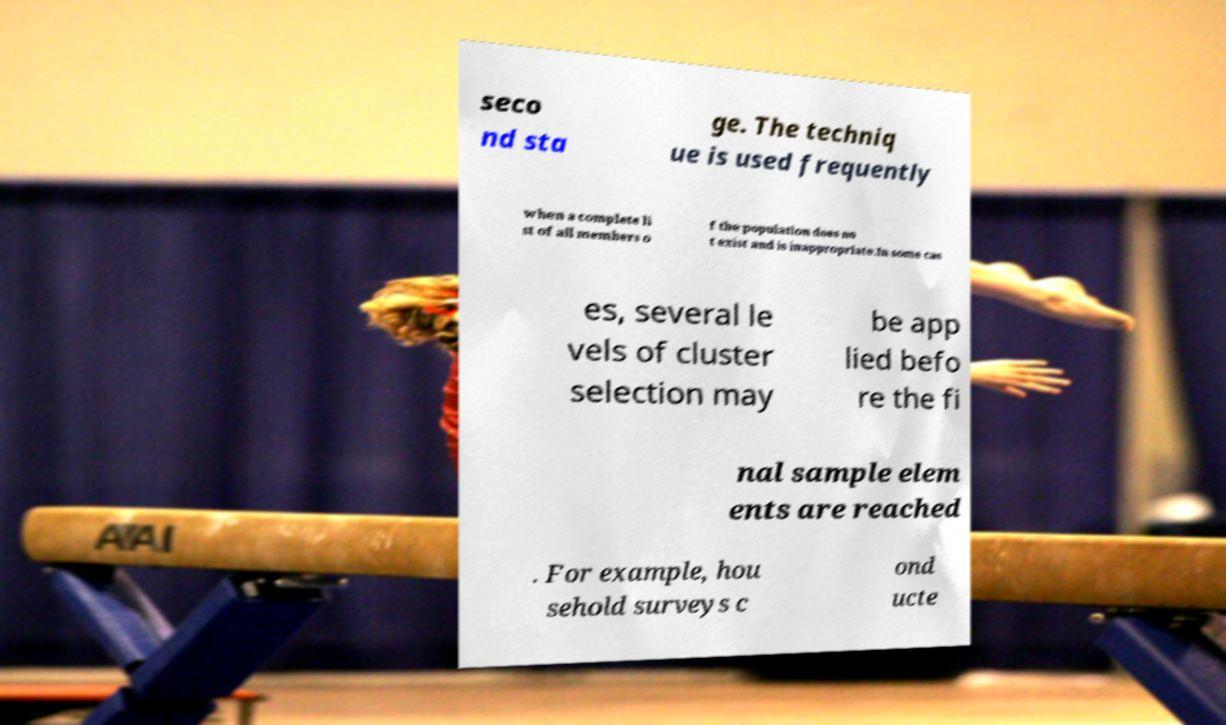I need the written content from this picture converted into text. Can you do that? seco nd sta ge. The techniq ue is used frequently when a complete li st of all members o f the population does no t exist and is inappropriate.In some cas es, several le vels of cluster selection may be app lied befo re the fi nal sample elem ents are reached . For example, hou sehold surveys c ond ucte 